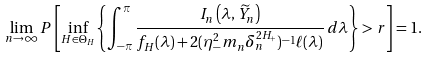<formula> <loc_0><loc_0><loc_500><loc_500>\lim _ { n \to \infty } P \left [ \inf _ { H \in \Theta _ { H } } \left \{ \int _ { - \pi } ^ { \pi } \frac { I _ { n } \left ( \lambda , \widetilde { Y } _ { n } \right ) } { f _ { H } ( \lambda ) + 2 ( \eta _ { - } ^ { 2 } m _ { n } \delta _ { n } ^ { 2 H _ { + } } ) ^ { - 1 } \ell ( \lambda ) } \, d \lambda \right \} > r \right ] = 1 .</formula> 